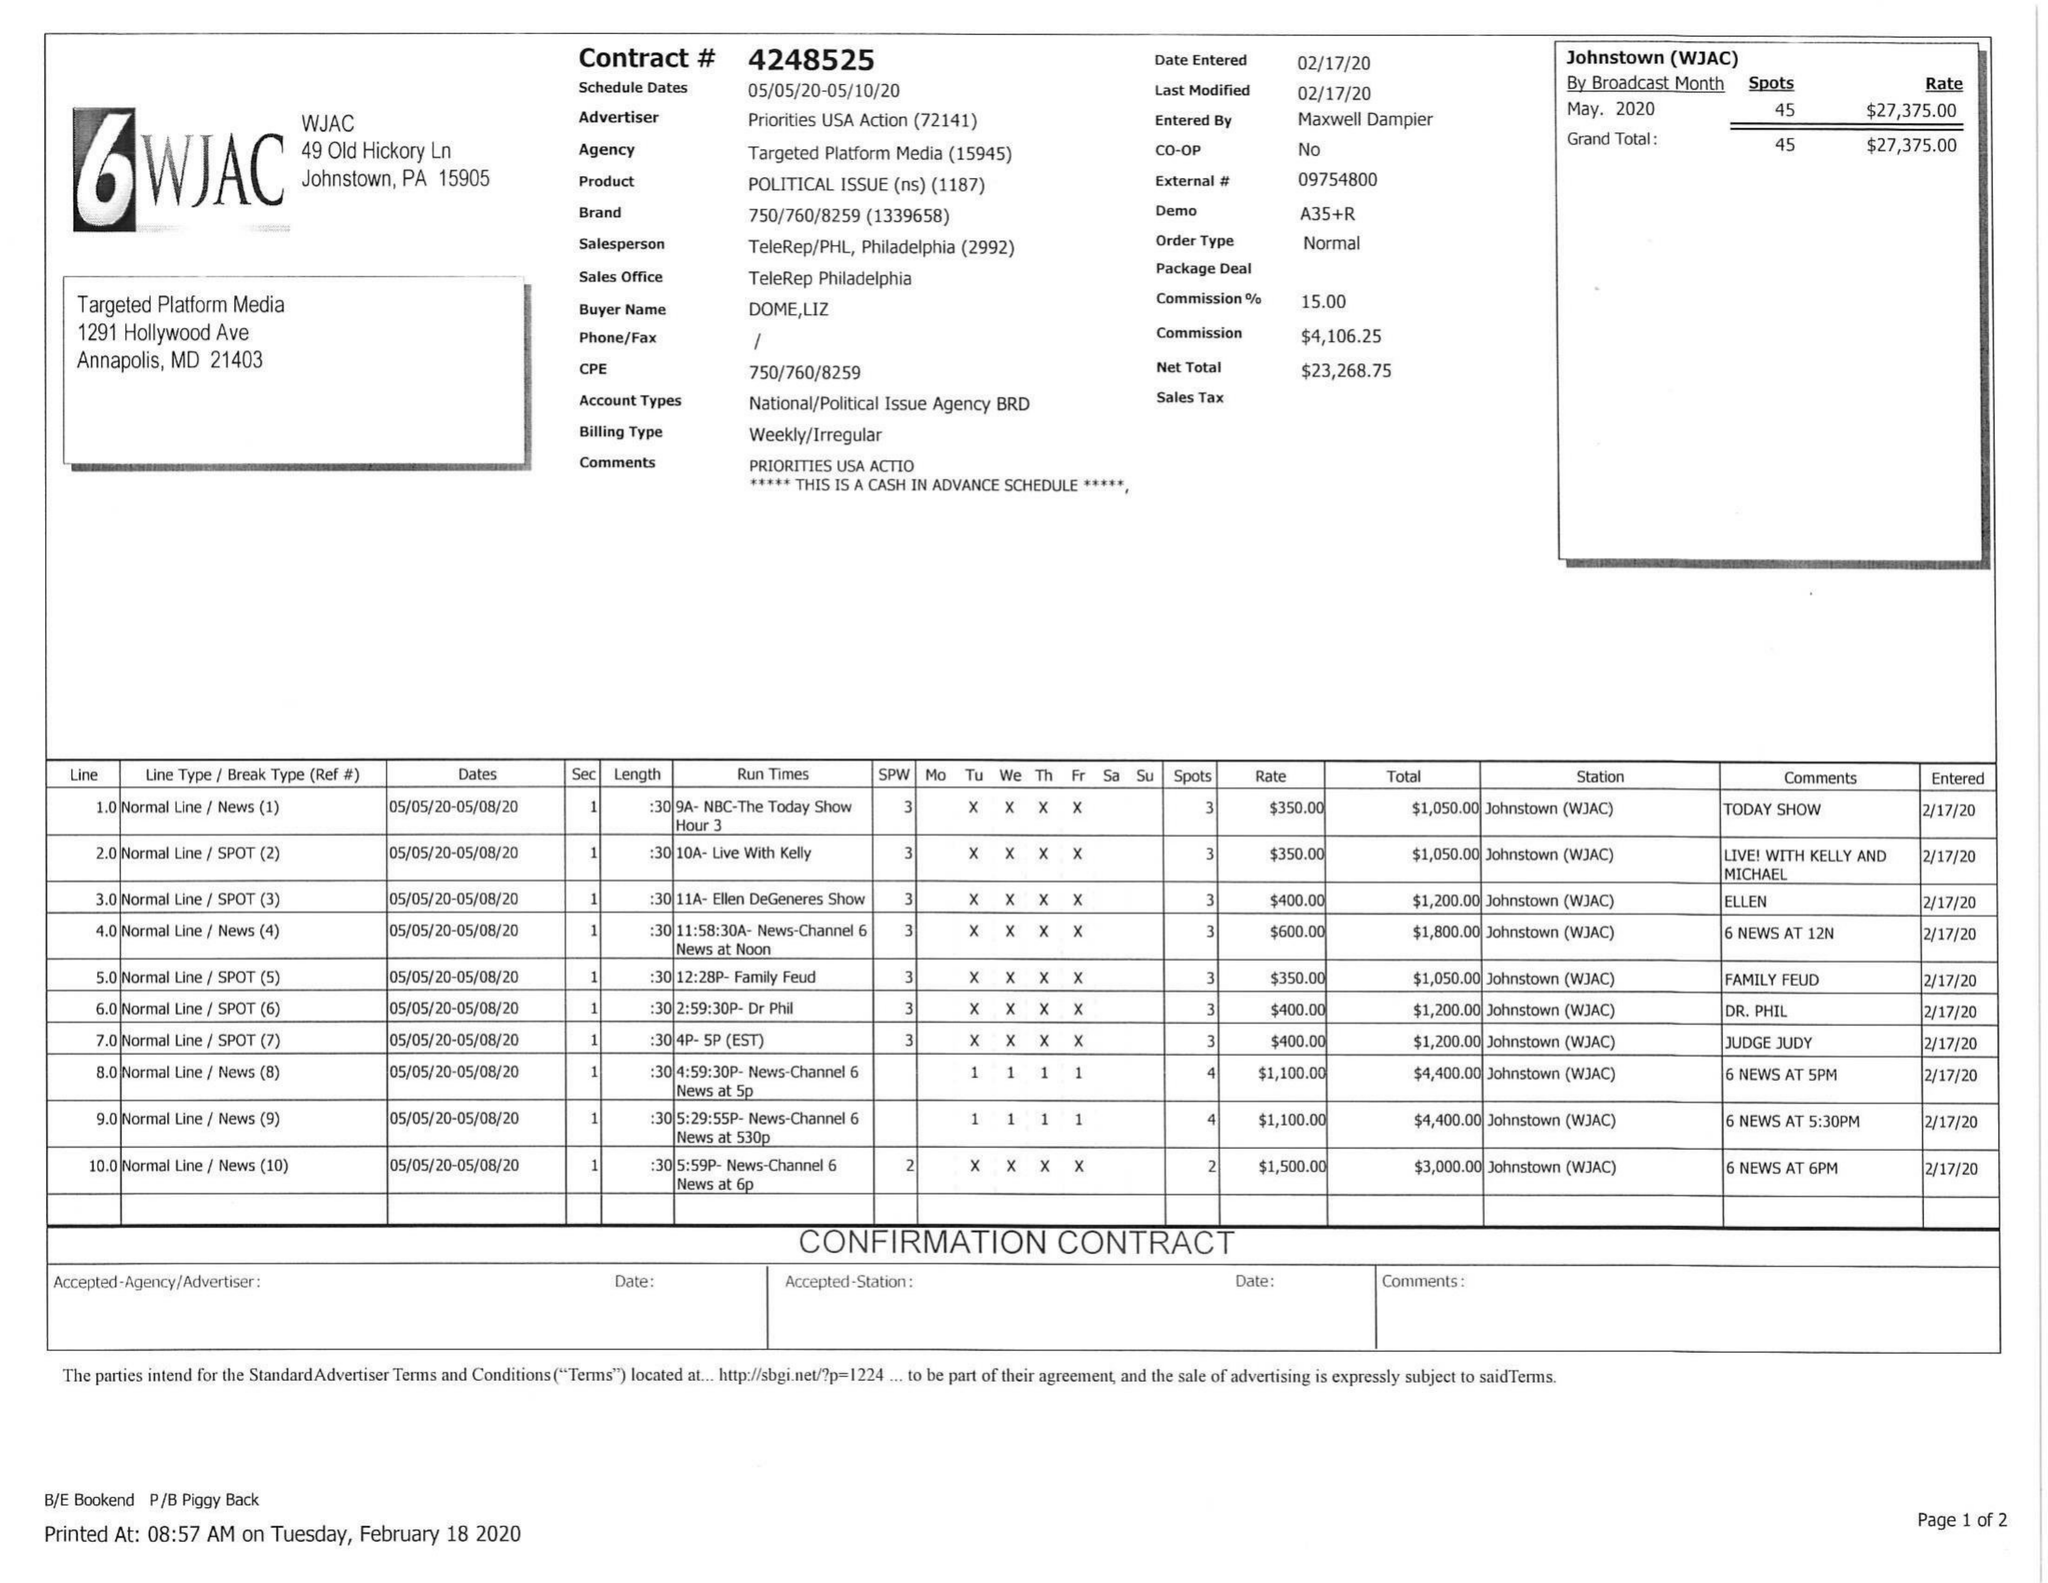What is the value for the contract_num?
Answer the question using a single word or phrase. 4248525 